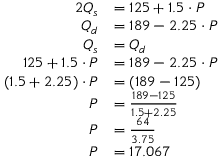Convert formula to latex. <formula><loc_0><loc_0><loc_500><loc_500>{ \begin{array} { r l } { { 2 } Q _ { s } } & { = 1 2 5 + 1 . 5 \cdot P } \\ { Q _ { d } } & { = 1 8 9 - 2 . 2 5 \cdot P } \\ { Q _ { s } } & { = Q _ { d } } \\ { 1 2 5 + 1 . 5 \cdot P } & { = 1 8 9 - 2 . 2 5 \cdot P } \\ { ( 1 . 5 + 2 . 2 5 ) \cdot P } & { = ( 1 8 9 - 1 2 5 ) } \\ { P } & { = { \frac { 1 8 9 - 1 2 5 } { 1 . 5 + 2 . 2 5 } } } \\ { P } & { = { \frac { 6 4 } { 3 . 7 5 } } } \\ { P } & { = 1 7 . 0 6 7 } \end{array} }</formula> 